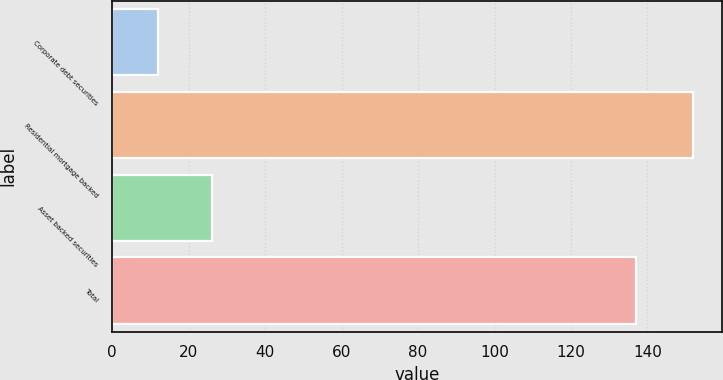Convert chart to OTSL. <chart><loc_0><loc_0><loc_500><loc_500><bar_chart><fcel>Corporate debt securities<fcel>Residential mortgage backed<fcel>Asset backed securities<fcel>Total<nl><fcel>12<fcel>152<fcel>26<fcel>137<nl></chart> 